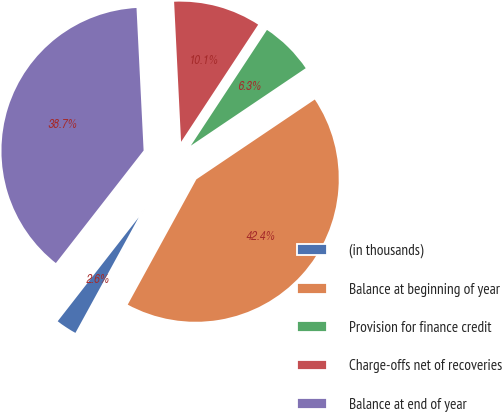<chart> <loc_0><loc_0><loc_500><loc_500><pie_chart><fcel>(in thousands)<fcel>Balance at beginning of year<fcel>Provision for finance credit<fcel>Charge-offs net of recoveries<fcel>Balance at end of year<nl><fcel>2.56%<fcel>42.42%<fcel>6.3%<fcel>10.05%<fcel>38.67%<nl></chart> 